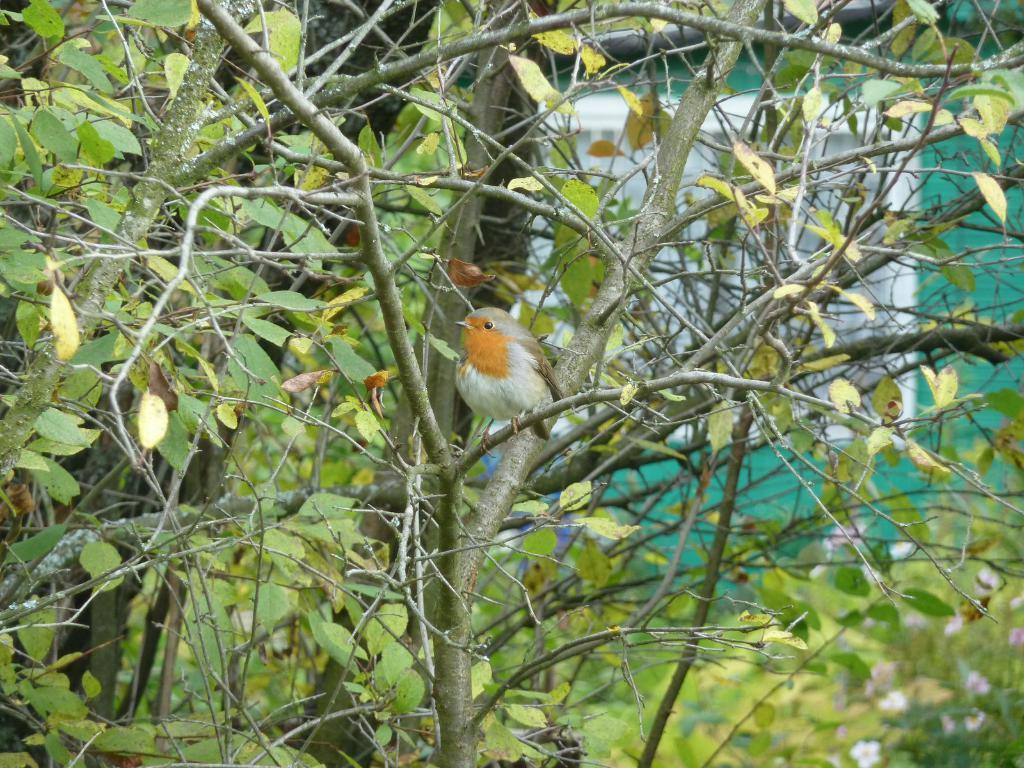What type of animal can be seen in the image? There is a bird in the image. Where is the bird located in the image? The bird is on a tree branch. What is the closest object to the camera in the image? There is a tree in the foreground of the image. What can be seen in the distance in the image? There is a building in the background of the image. How do the brothers express their anger towards the oven in the image? There are no brothers, anger, or oven present in the image; it features a bird on a tree branch with a tree in the foreground and a building in the background. 